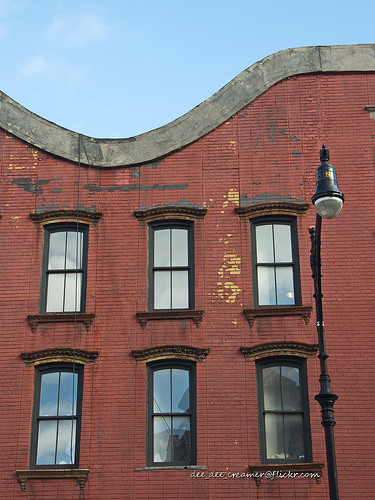<image>
Is there a window next to the street light? Yes. The window is positioned adjacent to the street light, located nearby in the same general area. Is there a light behind the window? No. The light is not behind the window. From this viewpoint, the light appears to be positioned elsewhere in the scene. 